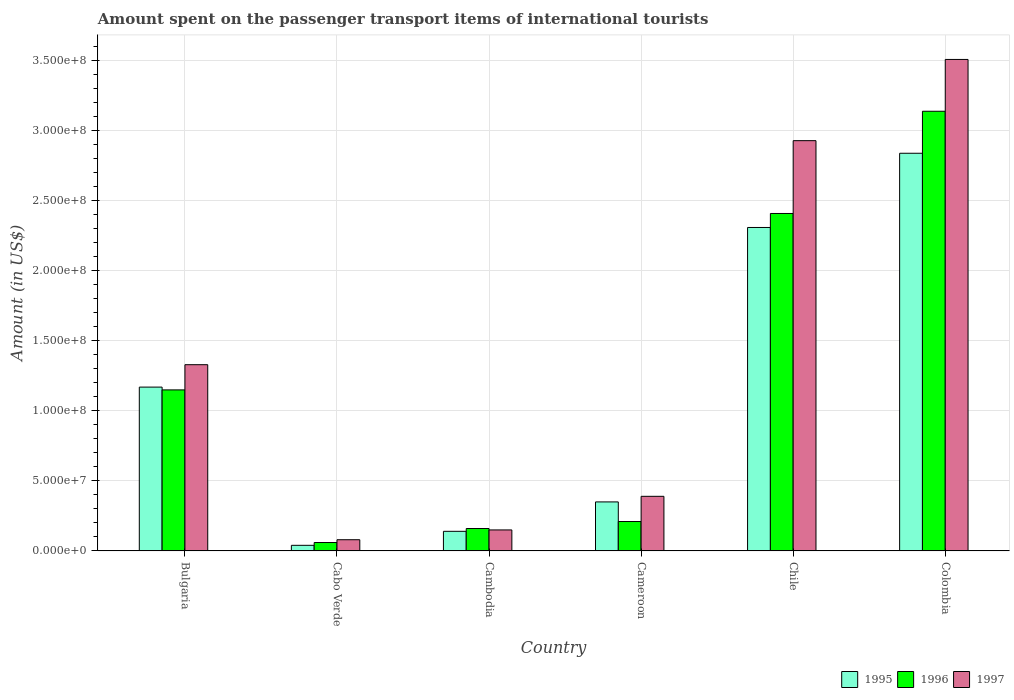How many different coloured bars are there?
Provide a succinct answer. 3. How many groups of bars are there?
Ensure brevity in your answer.  6. Are the number of bars on each tick of the X-axis equal?
Provide a succinct answer. Yes. How many bars are there on the 5th tick from the left?
Make the answer very short. 3. What is the label of the 4th group of bars from the left?
Offer a terse response. Cameroon. In how many cases, is the number of bars for a given country not equal to the number of legend labels?
Provide a short and direct response. 0. What is the amount spent on the passenger transport items of international tourists in 1997 in Cameroon?
Provide a succinct answer. 3.90e+07. Across all countries, what is the maximum amount spent on the passenger transport items of international tourists in 1997?
Offer a very short reply. 3.51e+08. Across all countries, what is the minimum amount spent on the passenger transport items of international tourists in 1995?
Make the answer very short. 4.00e+06. In which country was the amount spent on the passenger transport items of international tourists in 1996 minimum?
Give a very brief answer. Cabo Verde. What is the total amount spent on the passenger transport items of international tourists in 1996 in the graph?
Your answer should be compact. 7.13e+08. What is the difference between the amount spent on the passenger transport items of international tourists in 1996 in Bulgaria and that in Cabo Verde?
Keep it short and to the point. 1.09e+08. What is the difference between the amount spent on the passenger transport items of international tourists in 1995 in Chile and the amount spent on the passenger transport items of international tourists in 1996 in Colombia?
Keep it short and to the point. -8.30e+07. What is the average amount spent on the passenger transport items of international tourists in 1996 per country?
Provide a succinct answer. 1.19e+08. What is the ratio of the amount spent on the passenger transport items of international tourists in 1997 in Cabo Verde to that in Chile?
Give a very brief answer. 0.03. What is the difference between the highest and the second highest amount spent on the passenger transport items of international tourists in 1996?
Make the answer very short. 7.30e+07. What is the difference between the highest and the lowest amount spent on the passenger transport items of international tourists in 1997?
Your response must be concise. 3.43e+08. What does the 3rd bar from the right in Chile represents?
Make the answer very short. 1995. How many bars are there?
Your answer should be compact. 18. Are all the bars in the graph horizontal?
Your answer should be compact. No. What is the difference between two consecutive major ticks on the Y-axis?
Offer a very short reply. 5.00e+07. Where does the legend appear in the graph?
Ensure brevity in your answer.  Bottom right. What is the title of the graph?
Give a very brief answer. Amount spent on the passenger transport items of international tourists. What is the label or title of the Y-axis?
Your answer should be very brief. Amount (in US$). What is the Amount (in US$) in 1995 in Bulgaria?
Offer a very short reply. 1.17e+08. What is the Amount (in US$) in 1996 in Bulgaria?
Make the answer very short. 1.15e+08. What is the Amount (in US$) in 1997 in Bulgaria?
Your response must be concise. 1.33e+08. What is the Amount (in US$) in 1997 in Cabo Verde?
Offer a terse response. 8.00e+06. What is the Amount (in US$) in 1995 in Cambodia?
Your answer should be compact. 1.40e+07. What is the Amount (in US$) in 1996 in Cambodia?
Give a very brief answer. 1.60e+07. What is the Amount (in US$) in 1997 in Cambodia?
Make the answer very short. 1.50e+07. What is the Amount (in US$) in 1995 in Cameroon?
Give a very brief answer. 3.50e+07. What is the Amount (in US$) of 1996 in Cameroon?
Ensure brevity in your answer.  2.10e+07. What is the Amount (in US$) of 1997 in Cameroon?
Your response must be concise. 3.90e+07. What is the Amount (in US$) of 1995 in Chile?
Keep it short and to the point. 2.31e+08. What is the Amount (in US$) of 1996 in Chile?
Keep it short and to the point. 2.41e+08. What is the Amount (in US$) of 1997 in Chile?
Provide a succinct answer. 2.93e+08. What is the Amount (in US$) of 1995 in Colombia?
Offer a very short reply. 2.84e+08. What is the Amount (in US$) in 1996 in Colombia?
Keep it short and to the point. 3.14e+08. What is the Amount (in US$) in 1997 in Colombia?
Give a very brief answer. 3.51e+08. Across all countries, what is the maximum Amount (in US$) in 1995?
Ensure brevity in your answer.  2.84e+08. Across all countries, what is the maximum Amount (in US$) in 1996?
Offer a terse response. 3.14e+08. Across all countries, what is the maximum Amount (in US$) in 1997?
Keep it short and to the point. 3.51e+08. Across all countries, what is the minimum Amount (in US$) of 1995?
Ensure brevity in your answer.  4.00e+06. Across all countries, what is the minimum Amount (in US$) in 1997?
Your response must be concise. 8.00e+06. What is the total Amount (in US$) of 1995 in the graph?
Offer a very short reply. 6.85e+08. What is the total Amount (in US$) in 1996 in the graph?
Provide a short and direct response. 7.13e+08. What is the total Amount (in US$) in 1997 in the graph?
Provide a succinct answer. 8.39e+08. What is the difference between the Amount (in US$) in 1995 in Bulgaria and that in Cabo Verde?
Your response must be concise. 1.13e+08. What is the difference between the Amount (in US$) of 1996 in Bulgaria and that in Cabo Verde?
Give a very brief answer. 1.09e+08. What is the difference between the Amount (in US$) of 1997 in Bulgaria and that in Cabo Verde?
Keep it short and to the point. 1.25e+08. What is the difference between the Amount (in US$) in 1995 in Bulgaria and that in Cambodia?
Provide a short and direct response. 1.03e+08. What is the difference between the Amount (in US$) of 1996 in Bulgaria and that in Cambodia?
Your response must be concise. 9.90e+07. What is the difference between the Amount (in US$) of 1997 in Bulgaria and that in Cambodia?
Your answer should be very brief. 1.18e+08. What is the difference between the Amount (in US$) in 1995 in Bulgaria and that in Cameroon?
Keep it short and to the point. 8.20e+07. What is the difference between the Amount (in US$) in 1996 in Bulgaria and that in Cameroon?
Give a very brief answer. 9.40e+07. What is the difference between the Amount (in US$) in 1997 in Bulgaria and that in Cameroon?
Provide a succinct answer. 9.40e+07. What is the difference between the Amount (in US$) in 1995 in Bulgaria and that in Chile?
Offer a terse response. -1.14e+08. What is the difference between the Amount (in US$) in 1996 in Bulgaria and that in Chile?
Make the answer very short. -1.26e+08. What is the difference between the Amount (in US$) of 1997 in Bulgaria and that in Chile?
Your answer should be very brief. -1.60e+08. What is the difference between the Amount (in US$) of 1995 in Bulgaria and that in Colombia?
Provide a short and direct response. -1.67e+08. What is the difference between the Amount (in US$) in 1996 in Bulgaria and that in Colombia?
Your response must be concise. -1.99e+08. What is the difference between the Amount (in US$) of 1997 in Bulgaria and that in Colombia?
Your response must be concise. -2.18e+08. What is the difference between the Amount (in US$) of 1995 in Cabo Verde and that in Cambodia?
Ensure brevity in your answer.  -1.00e+07. What is the difference between the Amount (in US$) in 1996 in Cabo Verde and that in Cambodia?
Provide a short and direct response. -1.00e+07. What is the difference between the Amount (in US$) of 1997 in Cabo Verde and that in Cambodia?
Make the answer very short. -7.00e+06. What is the difference between the Amount (in US$) in 1995 in Cabo Verde and that in Cameroon?
Provide a short and direct response. -3.10e+07. What is the difference between the Amount (in US$) in 1996 in Cabo Verde and that in Cameroon?
Offer a very short reply. -1.50e+07. What is the difference between the Amount (in US$) of 1997 in Cabo Verde and that in Cameroon?
Your answer should be very brief. -3.10e+07. What is the difference between the Amount (in US$) in 1995 in Cabo Verde and that in Chile?
Your answer should be compact. -2.27e+08. What is the difference between the Amount (in US$) in 1996 in Cabo Verde and that in Chile?
Your answer should be compact. -2.35e+08. What is the difference between the Amount (in US$) of 1997 in Cabo Verde and that in Chile?
Offer a terse response. -2.85e+08. What is the difference between the Amount (in US$) of 1995 in Cabo Verde and that in Colombia?
Provide a short and direct response. -2.80e+08. What is the difference between the Amount (in US$) of 1996 in Cabo Verde and that in Colombia?
Make the answer very short. -3.08e+08. What is the difference between the Amount (in US$) of 1997 in Cabo Verde and that in Colombia?
Give a very brief answer. -3.43e+08. What is the difference between the Amount (in US$) of 1995 in Cambodia and that in Cameroon?
Ensure brevity in your answer.  -2.10e+07. What is the difference between the Amount (in US$) in 1996 in Cambodia and that in Cameroon?
Offer a terse response. -5.00e+06. What is the difference between the Amount (in US$) of 1997 in Cambodia and that in Cameroon?
Your response must be concise. -2.40e+07. What is the difference between the Amount (in US$) of 1995 in Cambodia and that in Chile?
Provide a short and direct response. -2.17e+08. What is the difference between the Amount (in US$) in 1996 in Cambodia and that in Chile?
Offer a terse response. -2.25e+08. What is the difference between the Amount (in US$) of 1997 in Cambodia and that in Chile?
Offer a terse response. -2.78e+08. What is the difference between the Amount (in US$) in 1995 in Cambodia and that in Colombia?
Provide a short and direct response. -2.70e+08. What is the difference between the Amount (in US$) in 1996 in Cambodia and that in Colombia?
Keep it short and to the point. -2.98e+08. What is the difference between the Amount (in US$) of 1997 in Cambodia and that in Colombia?
Give a very brief answer. -3.36e+08. What is the difference between the Amount (in US$) of 1995 in Cameroon and that in Chile?
Your answer should be compact. -1.96e+08. What is the difference between the Amount (in US$) in 1996 in Cameroon and that in Chile?
Provide a short and direct response. -2.20e+08. What is the difference between the Amount (in US$) of 1997 in Cameroon and that in Chile?
Your response must be concise. -2.54e+08. What is the difference between the Amount (in US$) in 1995 in Cameroon and that in Colombia?
Make the answer very short. -2.49e+08. What is the difference between the Amount (in US$) of 1996 in Cameroon and that in Colombia?
Your response must be concise. -2.93e+08. What is the difference between the Amount (in US$) in 1997 in Cameroon and that in Colombia?
Your answer should be very brief. -3.12e+08. What is the difference between the Amount (in US$) in 1995 in Chile and that in Colombia?
Provide a short and direct response. -5.30e+07. What is the difference between the Amount (in US$) of 1996 in Chile and that in Colombia?
Give a very brief answer. -7.30e+07. What is the difference between the Amount (in US$) in 1997 in Chile and that in Colombia?
Provide a succinct answer. -5.80e+07. What is the difference between the Amount (in US$) in 1995 in Bulgaria and the Amount (in US$) in 1996 in Cabo Verde?
Offer a terse response. 1.11e+08. What is the difference between the Amount (in US$) of 1995 in Bulgaria and the Amount (in US$) of 1997 in Cabo Verde?
Your answer should be compact. 1.09e+08. What is the difference between the Amount (in US$) of 1996 in Bulgaria and the Amount (in US$) of 1997 in Cabo Verde?
Offer a very short reply. 1.07e+08. What is the difference between the Amount (in US$) of 1995 in Bulgaria and the Amount (in US$) of 1996 in Cambodia?
Give a very brief answer. 1.01e+08. What is the difference between the Amount (in US$) of 1995 in Bulgaria and the Amount (in US$) of 1997 in Cambodia?
Keep it short and to the point. 1.02e+08. What is the difference between the Amount (in US$) in 1995 in Bulgaria and the Amount (in US$) in 1996 in Cameroon?
Give a very brief answer. 9.60e+07. What is the difference between the Amount (in US$) of 1995 in Bulgaria and the Amount (in US$) of 1997 in Cameroon?
Keep it short and to the point. 7.80e+07. What is the difference between the Amount (in US$) in 1996 in Bulgaria and the Amount (in US$) in 1997 in Cameroon?
Give a very brief answer. 7.60e+07. What is the difference between the Amount (in US$) in 1995 in Bulgaria and the Amount (in US$) in 1996 in Chile?
Provide a short and direct response. -1.24e+08. What is the difference between the Amount (in US$) in 1995 in Bulgaria and the Amount (in US$) in 1997 in Chile?
Ensure brevity in your answer.  -1.76e+08. What is the difference between the Amount (in US$) in 1996 in Bulgaria and the Amount (in US$) in 1997 in Chile?
Your response must be concise. -1.78e+08. What is the difference between the Amount (in US$) of 1995 in Bulgaria and the Amount (in US$) of 1996 in Colombia?
Your answer should be very brief. -1.97e+08. What is the difference between the Amount (in US$) of 1995 in Bulgaria and the Amount (in US$) of 1997 in Colombia?
Provide a succinct answer. -2.34e+08. What is the difference between the Amount (in US$) of 1996 in Bulgaria and the Amount (in US$) of 1997 in Colombia?
Ensure brevity in your answer.  -2.36e+08. What is the difference between the Amount (in US$) of 1995 in Cabo Verde and the Amount (in US$) of 1996 in Cambodia?
Make the answer very short. -1.20e+07. What is the difference between the Amount (in US$) in 1995 in Cabo Verde and the Amount (in US$) in 1997 in Cambodia?
Provide a succinct answer. -1.10e+07. What is the difference between the Amount (in US$) of 1996 in Cabo Verde and the Amount (in US$) of 1997 in Cambodia?
Your answer should be very brief. -9.00e+06. What is the difference between the Amount (in US$) in 1995 in Cabo Verde and the Amount (in US$) in 1996 in Cameroon?
Your answer should be very brief. -1.70e+07. What is the difference between the Amount (in US$) of 1995 in Cabo Verde and the Amount (in US$) of 1997 in Cameroon?
Ensure brevity in your answer.  -3.50e+07. What is the difference between the Amount (in US$) in 1996 in Cabo Verde and the Amount (in US$) in 1997 in Cameroon?
Give a very brief answer. -3.30e+07. What is the difference between the Amount (in US$) in 1995 in Cabo Verde and the Amount (in US$) in 1996 in Chile?
Give a very brief answer. -2.37e+08. What is the difference between the Amount (in US$) in 1995 in Cabo Verde and the Amount (in US$) in 1997 in Chile?
Offer a very short reply. -2.89e+08. What is the difference between the Amount (in US$) in 1996 in Cabo Verde and the Amount (in US$) in 1997 in Chile?
Make the answer very short. -2.87e+08. What is the difference between the Amount (in US$) of 1995 in Cabo Verde and the Amount (in US$) of 1996 in Colombia?
Provide a succinct answer. -3.10e+08. What is the difference between the Amount (in US$) of 1995 in Cabo Verde and the Amount (in US$) of 1997 in Colombia?
Keep it short and to the point. -3.47e+08. What is the difference between the Amount (in US$) in 1996 in Cabo Verde and the Amount (in US$) in 1997 in Colombia?
Your response must be concise. -3.45e+08. What is the difference between the Amount (in US$) of 1995 in Cambodia and the Amount (in US$) of 1996 in Cameroon?
Provide a short and direct response. -7.00e+06. What is the difference between the Amount (in US$) in 1995 in Cambodia and the Amount (in US$) in 1997 in Cameroon?
Your response must be concise. -2.50e+07. What is the difference between the Amount (in US$) in 1996 in Cambodia and the Amount (in US$) in 1997 in Cameroon?
Keep it short and to the point. -2.30e+07. What is the difference between the Amount (in US$) of 1995 in Cambodia and the Amount (in US$) of 1996 in Chile?
Keep it short and to the point. -2.27e+08. What is the difference between the Amount (in US$) of 1995 in Cambodia and the Amount (in US$) of 1997 in Chile?
Give a very brief answer. -2.79e+08. What is the difference between the Amount (in US$) in 1996 in Cambodia and the Amount (in US$) in 1997 in Chile?
Offer a terse response. -2.77e+08. What is the difference between the Amount (in US$) in 1995 in Cambodia and the Amount (in US$) in 1996 in Colombia?
Your answer should be compact. -3.00e+08. What is the difference between the Amount (in US$) of 1995 in Cambodia and the Amount (in US$) of 1997 in Colombia?
Make the answer very short. -3.37e+08. What is the difference between the Amount (in US$) in 1996 in Cambodia and the Amount (in US$) in 1997 in Colombia?
Keep it short and to the point. -3.35e+08. What is the difference between the Amount (in US$) of 1995 in Cameroon and the Amount (in US$) of 1996 in Chile?
Offer a very short reply. -2.06e+08. What is the difference between the Amount (in US$) of 1995 in Cameroon and the Amount (in US$) of 1997 in Chile?
Make the answer very short. -2.58e+08. What is the difference between the Amount (in US$) in 1996 in Cameroon and the Amount (in US$) in 1997 in Chile?
Give a very brief answer. -2.72e+08. What is the difference between the Amount (in US$) of 1995 in Cameroon and the Amount (in US$) of 1996 in Colombia?
Keep it short and to the point. -2.79e+08. What is the difference between the Amount (in US$) of 1995 in Cameroon and the Amount (in US$) of 1997 in Colombia?
Ensure brevity in your answer.  -3.16e+08. What is the difference between the Amount (in US$) of 1996 in Cameroon and the Amount (in US$) of 1997 in Colombia?
Make the answer very short. -3.30e+08. What is the difference between the Amount (in US$) in 1995 in Chile and the Amount (in US$) in 1996 in Colombia?
Make the answer very short. -8.30e+07. What is the difference between the Amount (in US$) of 1995 in Chile and the Amount (in US$) of 1997 in Colombia?
Give a very brief answer. -1.20e+08. What is the difference between the Amount (in US$) in 1996 in Chile and the Amount (in US$) in 1997 in Colombia?
Offer a terse response. -1.10e+08. What is the average Amount (in US$) of 1995 per country?
Offer a very short reply. 1.14e+08. What is the average Amount (in US$) of 1996 per country?
Keep it short and to the point. 1.19e+08. What is the average Amount (in US$) in 1997 per country?
Make the answer very short. 1.40e+08. What is the difference between the Amount (in US$) of 1995 and Amount (in US$) of 1996 in Bulgaria?
Keep it short and to the point. 2.00e+06. What is the difference between the Amount (in US$) of 1995 and Amount (in US$) of 1997 in Bulgaria?
Offer a very short reply. -1.60e+07. What is the difference between the Amount (in US$) in 1996 and Amount (in US$) in 1997 in Bulgaria?
Offer a very short reply. -1.80e+07. What is the difference between the Amount (in US$) of 1995 and Amount (in US$) of 1997 in Cabo Verde?
Provide a succinct answer. -4.00e+06. What is the difference between the Amount (in US$) of 1995 and Amount (in US$) of 1996 in Cambodia?
Offer a very short reply. -2.00e+06. What is the difference between the Amount (in US$) in 1995 and Amount (in US$) in 1996 in Cameroon?
Give a very brief answer. 1.40e+07. What is the difference between the Amount (in US$) of 1996 and Amount (in US$) of 1997 in Cameroon?
Your response must be concise. -1.80e+07. What is the difference between the Amount (in US$) in 1995 and Amount (in US$) in 1996 in Chile?
Give a very brief answer. -1.00e+07. What is the difference between the Amount (in US$) in 1995 and Amount (in US$) in 1997 in Chile?
Your answer should be compact. -6.20e+07. What is the difference between the Amount (in US$) in 1996 and Amount (in US$) in 1997 in Chile?
Offer a very short reply. -5.20e+07. What is the difference between the Amount (in US$) of 1995 and Amount (in US$) of 1996 in Colombia?
Make the answer very short. -3.00e+07. What is the difference between the Amount (in US$) in 1995 and Amount (in US$) in 1997 in Colombia?
Offer a terse response. -6.70e+07. What is the difference between the Amount (in US$) in 1996 and Amount (in US$) in 1997 in Colombia?
Keep it short and to the point. -3.70e+07. What is the ratio of the Amount (in US$) of 1995 in Bulgaria to that in Cabo Verde?
Provide a succinct answer. 29.25. What is the ratio of the Amount (in US$) in 1996 in Bulgaria to that in Cabo Verde?
Provide a succinct answer. 19.17. What is the ratio of the Amount (in US$) of 1997 in Bulgaria to that in Cabo Verde?
Ensure brevity in your answer.  16.62. What is the ratio of the Amount (in US$) in 1995 in Bulgaria to that in Cambodia?
Ensure brevity in your answer.  8.36. What is the ratio of the Amount (in US$) of 1996 in Bulgaria to that in Cambodia?
Your answer should be compact. 7.19. What is the ratio of the Amount (in US$) in 1997 in Bulgaria to that in Cambodia?
Provide a succinct answer. 8.87. What is the ratio of the Amount (in US$) in 1995 in Bulgaria to that in Cameroon?
Your response must be concise. 3.34. What is the ratio of the Amount (in US$) of 1996 in Bulgaria to that in Cameroon?
Keep it short and to the point. 5.48. What is the ratio of the Amount (in US$) of 1997 in Bulgaria to that in Cameroon?
Give a very brief answer. 3.41. What is the ratio of the Amount (in US$) of 1995 in Bulgaria to that in Chile?
Ensure brevity in your answer.  0.51. What is the ratio of the Amount (in US$) of 1996 in Bulgaria to that in Chile?
Offer a terse response. 0.48. What is the ratio of the Amount (in US$) of 1997 in Bulgaria to that in Chile?
Your answer should be very brief. 0.45. What is the ratio of the Amount (in US$) of 1995 in Bulgaria to that in Colombia?
Keep it short and to the point. 0.41. What is the ratio of the Amount (in US$) of 1996 in Bulgaria to that in Colombia?
Keep it short and to the point. 0.37. What is the ratio of the Amount (in US$) in 1997 in Bulgaria to that in Colombia?
Keep it short and to the point. 0.38. What is the ratio of the Amount (in US$) in 1995 in Cabo Verde to that in Cambodia?
Make the answer very short. 0.29. What is the ratio of the Amount (in US$) of 1997 in Cabo Verde to that in Cambodia?
Make the answer very short. 0.53. What is the ratio of the Amount (in US$) in 1995 in Cabo Verde to that in Cameroon?
Provide a short and direct response. 0.11. What is the ratio of the Amount (in US$) of 1996 in Cabo Verde to that in Cameroon?
Offer a very short reply. 0.29. What is the ratio of the Amount (in US$) in 1997 in Cabo Verde to that in Cameroon?
Make the answer very short. 0.21. What is the ratio of the Amount (in US$) of 1995 in Cabo Verde to that in Chile?
Keep it short and to the point. 0.02. What is the ratio of the Amount (in US$) in 1996 in Cabo Verde to that in Chile?
Your answer should be compact. 0.02. What is the ratio of the Amount (in US$) of 1997 in Cabo Verde to that in Chile?
Ensure brevity in your answer.  0.03. What is the ratio of the Amount (in US$) in 1995 in Cabo Verde to that in Colombia?
Offer a very short reply. 0.01. What is the ratio of the Amount (in US$) of 1996 in Cabo Verde to that in Colombia?
Give a very brief answer. 0.02. What is the ratio of the Amount (in US$) in 1997 in Cabo Verde to that in Colombia?
Your answer should be compact. 0.02. What is the ratio of the Amount (in US$) of 1996 in Cambodia to that in Cameroon?
Ensure brevity in your answer.  0.76. What is the ratio of the Amount (in US$) in 1997 in Cambodia to that in Cameroon?
Offer a very short reply. 0.38. What is the ratio of the Amount (in US$) in 1995 in Cambodia to that in Chile?
Provide a succinct answer. 0.06. What is the ratio of the Amount (in US$) in 1996 in Cambodia to that in Chile?
Your answer should be very brief. 0.07. What is the ratio of the Amount (in US$) of 1997 in Cambodia to that in Chile?
Offer a terse response. 0.05. What is the ratio of the Amount (in US$) of 1995 in Cambodia to that in Colombia?
Offer a terse response. 0.05. What is the ratio of the Amount (in US$) in 1996 in Cambodia to that in Colombia?
Offer a very short reply. 0.05. What is the ratio of the Amount (in US$) in 1997 in Cambodia to that in Colombia?
Your response must be concise. 0.04. What is the ratio of the Amount (in US$) of 1995 in Cameroon to that in Chile?
Offer a very short reply. 0.15. What is the ratio of the Amount (in US$) in 1996 in Cameroon to that in Chile?
Your response must be concise. 0.09. What is the ratio of the Amount (in US$) of 1997 in Cameroon to that in Chile?
Give a very brief answer. 0.13. What is the ratio of the Amount (in US$) in 1995 in Cameroon to that in Colombia?
Your answer should be compact. 0.12. What is the ratio of the Amount (in US$) in 1996 in Cameroon to that in Colombia?
Provide a short and direct response. 0.07. What is the ratio of the Amount (in US$) in 1995 in Chile to that in Colombia?
Provide a succinct answer. 0.81. What is the ratio of the Amount (in US$) of 1996 in Chile to that in Colombia?
Your response must be concise. 0.77. What is the ratio of the Amount (in US$) in 1997 in Chile to that in Colombia?
Provide a short and direct response. 0.83. What is the difference between the highest and the second highest Amount (in US$) in 1995?
Ensure brevity in your answer.  5.30e+07. What is the difference between the highest and the second highest Amount (in US$) of 1996?
Provide a succinct answer. 7.30e+07. What is the difference between the highest and the second highest Amount (in US$) in 1997?
Offer a terse response. 5.80e+07. What is the difference between the highest and the lowest Amount (in US$) in 1995?
Make the answer very short. 2.80e+08. What is the difference between the highest and the lowest Amount (in US$) of 1996?
Offer a very short reply. 3.08e+08. What is the difference between the highest and the lowest Amount (in US$) of 1997?
Your answer should be very brief. 3.43e+08. 